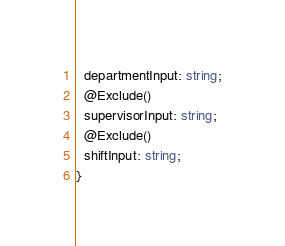Convert code to text. <code><loc_0><loc_0><loc_500><loc_500><_TypeScript_>  departmentInput: string;
  @Exclude()
  supervisorInput: string;
  @Exclude()
  shiftInput: string;
}
</code> 